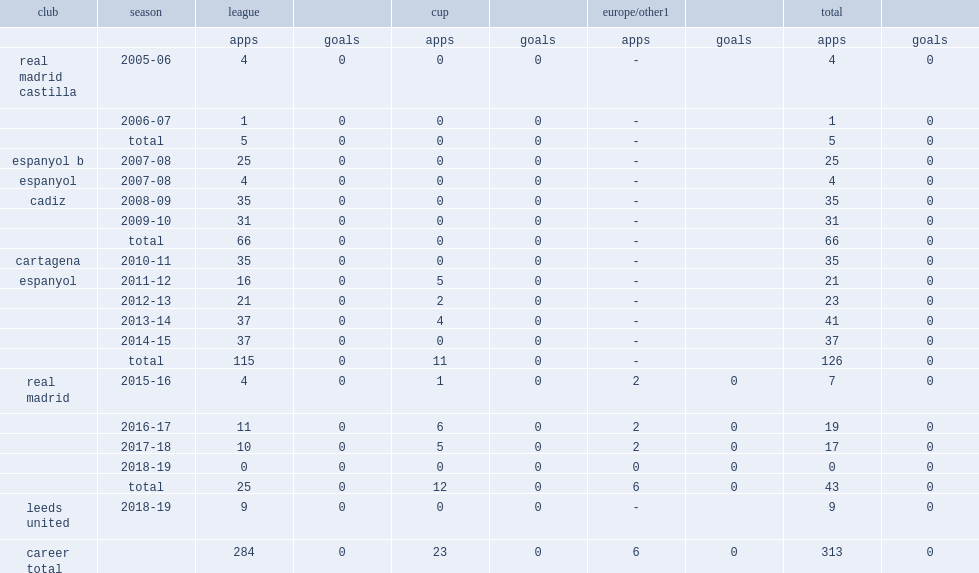What was the total number of appearances made by kiko casilla for espanyol? 126.0. 